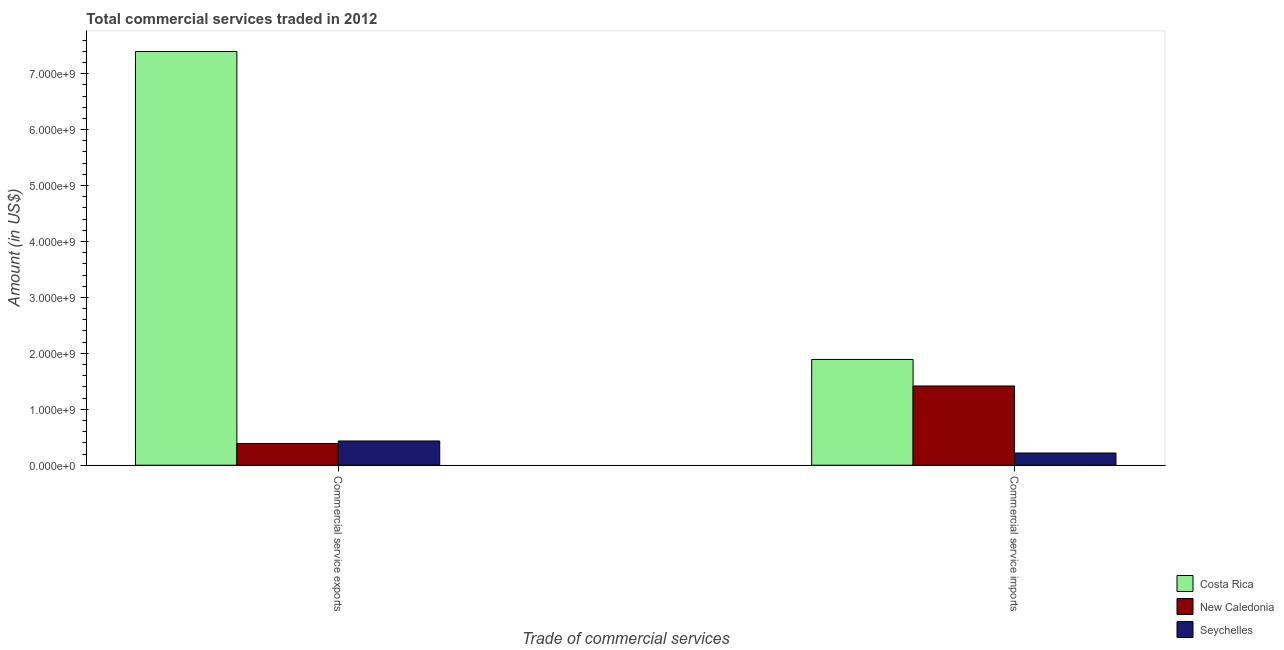How many different coloured bars are there?
Your answer should be compact. 3. How many groups of bars are there?
Make the answer very short. 2. Are the number of bars per tick equal to the number of legend labels?
Your answer should be very brief. Yes. How many bars are there on the 2nd tick from the left?
Offer a terse response. 3. How many bars are there on the 2nd tick from the right?
Your answer should be very brief. 3. What is the label of the 2nd group of bars from the left?
Provide a short and direct response. Commercial service imports. What is the amount of commercial service exports in Seychelles?
Offer a terse response. 4.33e+08. Across all countries, what is the maximum amount of commercial service imports?
Provide a succinct answer. 1.89e+09. Across all countries, what is the minimum amount of commercial service exports?
Offer a terse response. 3.88e+08. In which country was the amount of commercial service imports minimum?
Keep it short and to the point. Seychelles. What is the total amount of commercial service imports in the graph?
Make the answer very short. 3.53e+09. What is the difference between the amount of commercial service exports in Seychelles and that in New Caledonia?
Your answer should be compact. 4.54e+07. What is the difference between the amount of commercial service imports in New Caledonia and the amount of commercial service exports in Costa Rica?
Ensure brevity in your answer.  -5.98e+09. What is the average amount of commercial service imports per country?
Offer a terse response. 1.18e+09. What is the difference between the amount of commercial service exports and amount of commercial service imports in Costa Rica?
Give a very brief answer. 5.51e+09. In how many countries, is the amount of commercial service exports greater than 1000000000 US$?
Give a very brief answer. 1. What is the ratio of the amount of commercial service imports in Seychelles to that in New Caledonia?
Make the answer very short. 0.15. Is the amount of commercial service exports in New Caledonia less than that in Seychelles?
Provide a succinct answer. Yes. What does the 2nd bar from the left in Commercial service imports represents?
Ensure brevity in your answer.  New Caledonia. What does the 1st bar from the right in Commercial service imports represents?
Keep it short and to the point. Seychelles. How many bars are there?
Your answer should be very brief. 6. How many countries are there in the graph?
Offer a terse response. 3. What is the difference between two consecutive major ticks on the Y-axis?
Provide a succinct answer. 1.00e+09. Are the values on the major ticks of Y-axis written in scientific E-notation?
Give a very brief answer. Yes. Does the graph contain any zero values?
Give a very brief answer. No. Where does the legend appear in the graph?
Keep it short and to the point. Bottom right. How many legend labels are there?
Make the answer very short. 3. How are the legend labels stacked?
Ensure brevity in your answer.  Vertical. What is the title of the graph?
Your answer should be compact. Total commercial services traded in 2012. What is the label or title of the X-axis?
Provide a succinct answer. Trade of commercial services. What is the label or title of the Y-axis?
Offer a terse response. Amount (in US$). What is the Amount (in US$) in Costa Rica in Commercial service exports?
Keep it short and to the point. 7.40e+09. What is the Amount (in US$) of New Caledonia in Commercial service exports?
Keep it short and to the point. 3.88e+08. What is the Amount (in US$) in Seychelles in Commercial service exports?
Provide a short and direct response. 4.33e+08. What is the Amount (in US$) in Costa Rica in Commercial service imports?
Provide a succinct answer. 1.89e+09. What is the Amount (in US$) in New Caledonia in Commercial service imports?
Your answer should be compact. 1.42e+09. What is the Amount (in US$) of Seychelles in Commercial service imports?
Ensure brevity in your answer.  2.18e+08. Across all Trade of commercial services, what is the maximum Amount (in US$) of Costa Rica?
Your answer should be compact. 7.40e+09. Across all Trade of commercial services, what is the maximum Amount (in US$) of New Caledonia?
Provide a succinct answer. 1.42e+09. Across all Trade of commercial services, what is the maximum Amount (in US$) in Seychelles?
Make the answer very short. 4.33e+08. Across all Trade of commercial services, what is the minimum Amount (in US$) in Costa Rica?
Provide a short and direct response. 1.89e+09. Across all Trade of commercial services, what is the minimum Amount (in US$) of New Caledonia?
Make the answer very short. 3.88e+08. Across all Trade of commercial services, what is the minimum Amount (in US$) in Seychelles?
Provide a short and direct response. 2.18e+08. What is the total Amount (in US$) in Costa Rica in the graph?
Your answer should be compact. 9.29e+09. What is the total Amount (in US$) in New Caledonia in the graph?
Provide a succinct answer. 1.80e+09. What is the total Amount (in US$) in Seychelles in the graph?
Your answer should be compact. 6.51e+08. What is the difference between the Amount (in US$) in Costa Rica in Commercial service exports and that in Commercial service imports?
Offer a terse response. 5.51e+09. What is the difference between the Amount (in US$) of New Caledonia in Commercial service exports and that in Commercial service imports?
Offer a very short reply. -1.03e+09. What is the difference between the Amount (in US$) of Seychelles in Commercial service exports and that in Commercial service imports?
Provide a succinct answer. 2.15e+08. What is the difference between the Amount (in US$) in Costa Rica in Commercial service exports and the Amount (in US$) in New Caledonia in Commercial service imports?
Your answer should be compact. 5.98e+09. What is the difference between the Amount (in US$) in Costa Rica in Commercial service exports and the Amount (in US$) in Seychelles in Commercial service imports?
Ensure brevity in your answer.  7.18e+09. What is the difference between the Amount (in US$) of New Caledonia in Commercial service exports and the Amount (in US$) of Seychelles in Commercial service imports?
Provide a short and direct response. 1.70e+08. What is the average Amount (in US$) in Costa Rica per Trade of commercial services?
Provide a short and direct response. 4.64e+09. What is the average Amount (in US$) of New Caledonia per Trade of commercial services?
Provide a short and direct response. 9.02e+08. What is the average Amount (in US$) in Seychelles per Trade of commercial services?
Offer a very short reply. 3.26e+08. What is the difference between the Amount (in US$) of Costa Rica and Amount (in US$) of New Caledonia in Commercial service exports?
Offer a very short reply. 7.01e+09. What is the difference between the Amount (in US$) of Costa Rica and Amount (in US$) of Seychelles in Commercial service exports?
Make the answer very short. 6.96e+09. What is the difference between the Amount (in US$) of New Caledonia and Amount (in US$) of Seychelles in Commercial service exports?
Make the answer very short. -4.54e+07. What is the difference between the Amount (in US$) in Costa Rica and Amount (in US$) in New Caledonia in Commercial service imports?
Your response must be concise. 4.74e+08. What is the difference between the Amount (in US$) in Costa Rica and Amount (in US$) in Seychelles in Commercial service imports?
Provide a succinct answer. 1.67e+09. What is the difference between the Amount (in US$) in New Caledonia and Amount (in US$) in Seychelles in Commercial service imports?
Offer a very short reply. 1.20e+09. What is the ratio of the Amount (in US$) in Costa Rica in Commercial service exports to that in Commercial service imports?
Make the answer very short. 3.91. What is the ratio of the Amount (in US$) in New Caledonia in Commercial service exports to that in Commercial service imports?
Offer a very short reply. 0.27. What is the ratio of the Amount (in US$) of Seychelles in Commercial service exports to that in Commercial service imports?
Your answer should be compact. 1.99. What is the difference between the highest and the second highest Amount (in US$) of Costa Rica?
Ensure brevity in your answer.  5.51e+09. What is the difference between the highest and the second highest Amount (in US$) in New Caledonia?
Provide a succinct answer. 1.03e+09. What is the difference between the highest and the second highest Amount (in US$) of Seychelles?
Offer a very short reply. 2.15e+08. What is the difference between the highest and the lowest Amount (in US$) in Costa Rica?
Keep it short and to the point. 5.51e+09. What is the difference between the highest and the lowest Amount (in US$) of New Caledonia?
Make the answer very short. 1.03e+09. What is the difference between the highest and the lowest Amount (in US$) of Seychelles?
Provide a succinct answer. 2.15e+08. 